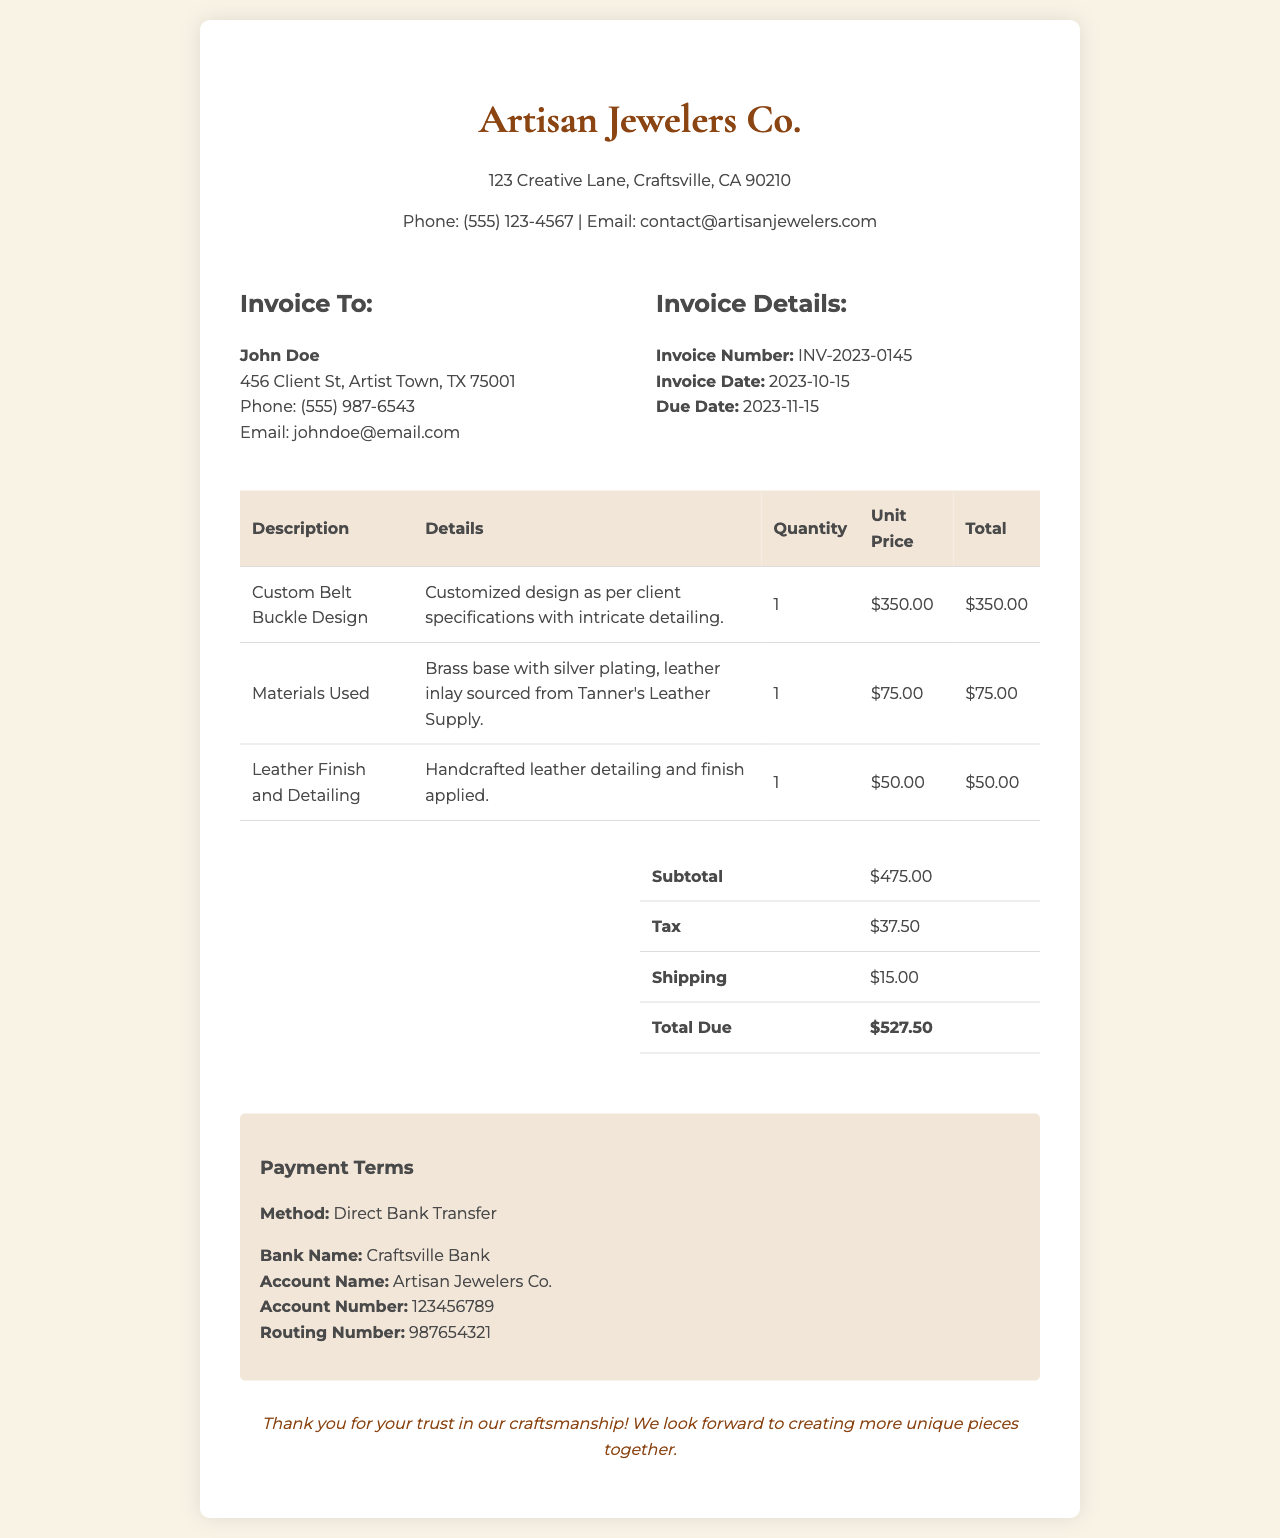What is the invoice number? The invoice number is listed in the invoice details section.
Answer: INV-2023-0145 Who is the invoice addressed to? The invoice is directed to the client, John Doe, as mentioned in the invoice details.
Answer: John Doe What is the total amount due? The total amount due is calculated in the summary section of the invoice.
Answer: $527.50 What materials were used for the belt buckle? The materials used for the belt buckle are specified in the table under "Materials Used."
Answer: Brass base with silver plating, leather inlay What is the due date for the invoice? The due date is listed in the invoice details section.
Answer: 2023-11-15 How much was charged for the custom design? The cost for the custom belt buckle design is found in the table detailing the charges.
Answer: $350.00 What is the payment method? The payment method is listed in the payment terms section.
Answer: Direct Bank Transfer What is the subtotal before tax and shipping? The subtotal is specified in the summary section of the invoice.
Answer: $475.00 Where is the company located? The company's address is displayed at the top of the invoice.
Answer: 123 Creative Lane, Craftsville, CA 90210 